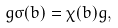Convert formula to latex. <formula><loc_0><loc_0><loc_500><loc_500>g \sigma ( b ) = \chi ( b ) g ,</formula> 